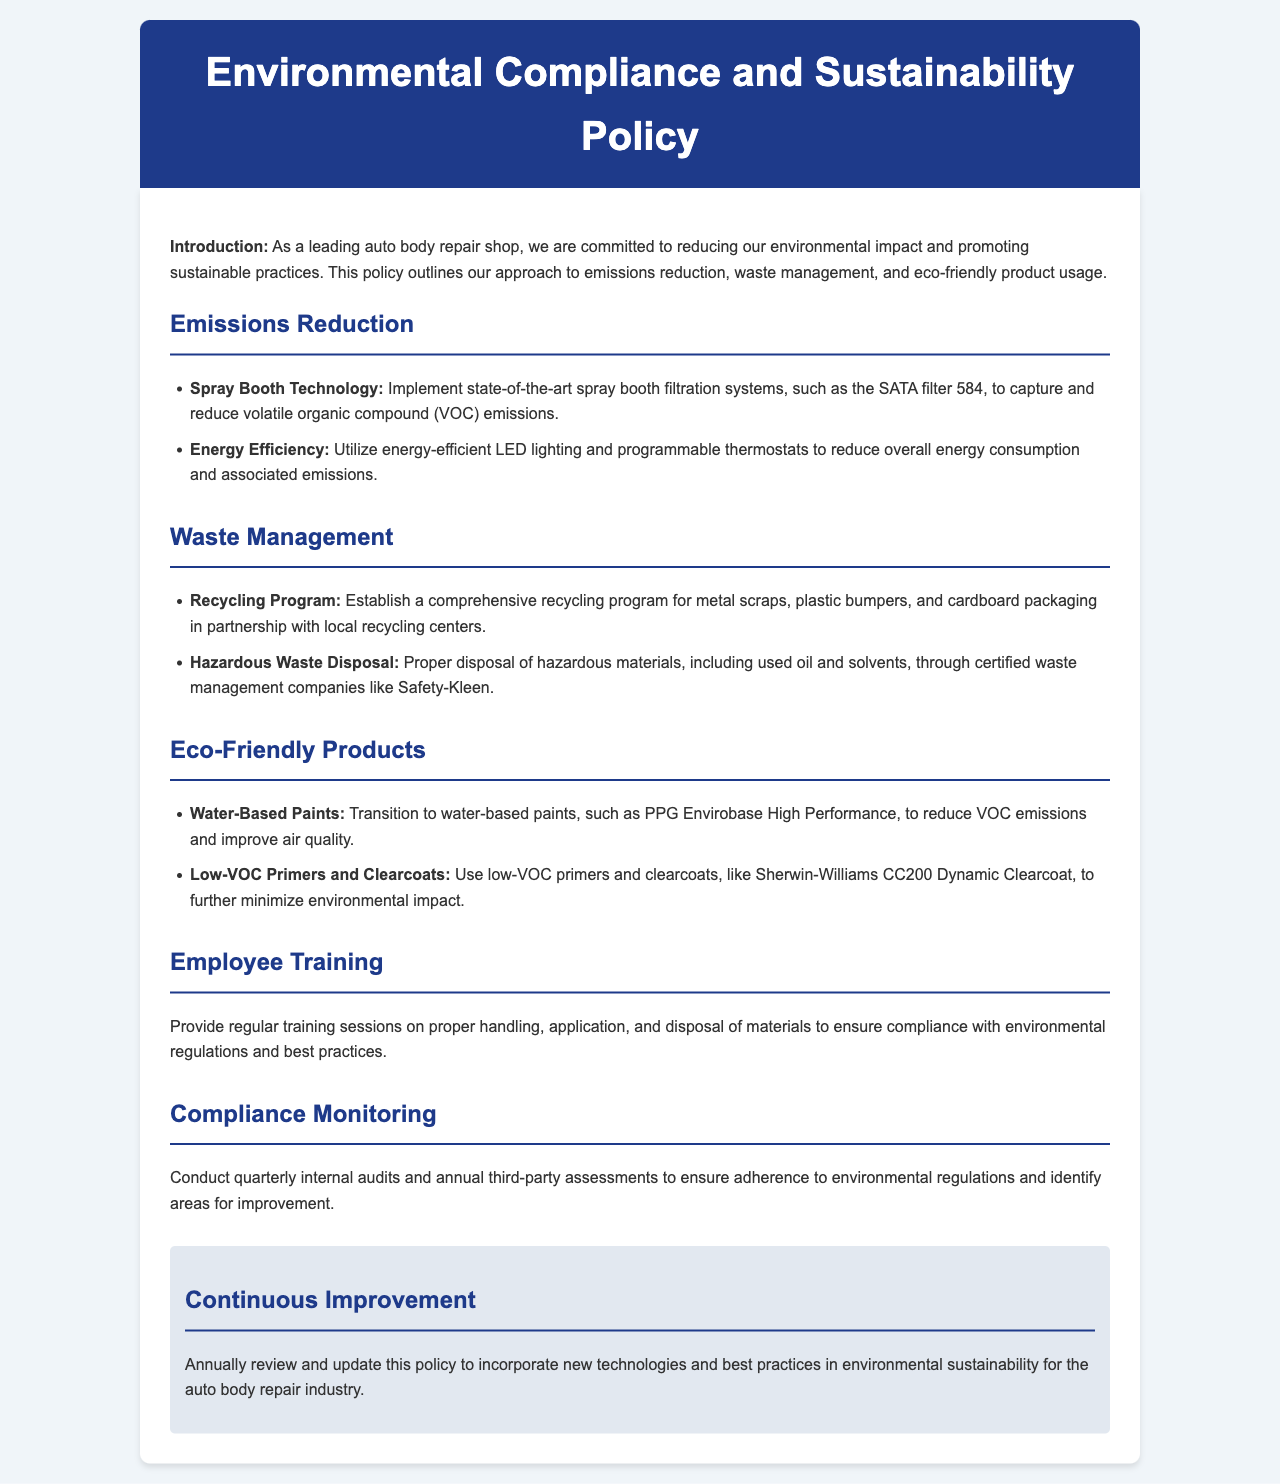What is the primary focus of the policy? The introductory paragraph states that the policy is aimed at reducing the environmental impact and promoting sustainable practices.
Answer: Reducing environmental impact What type of spray booth is recommended? The document mentions implementing state-of-the-art spray booth filtration systems like the SATA filter 584.
Answer: SATA filter 584 What products are suggested for minimizing VOC emissions? The policy includes recommendations for water-based paints like PPG Envirobase High Performance and low-VOC primers and clearcoats.
Answer: PPG Envirobase High Performance How often are internal audits conducted? The compliance section specifies that internal audits are conducted quarterly.
Answer: Quarterly What company is mentioned for hazardous waste disposal? The policy outlines proper disposal through certified waste management companies, specifically naming Safety-Kleen.
Answer: Safety-Kleen Which eco-friendly paint product is specified? Water-based paints are emphasized, with an example provided in the document.
Answer: Water-based paints What is the frequency of employee training? The document does not specify a frequency, but it states that regular training sessions are provided.
Answer: Regular How is compliance monitored? The document states that compliance is monitored through quarterly internal audits and annual third-party assessments.
Answer: Quarterly audits and annual assessments What is the goal for policy review? The highlight section indicates the goal is to annually review and update the policy.
Answer: Annually review and update 